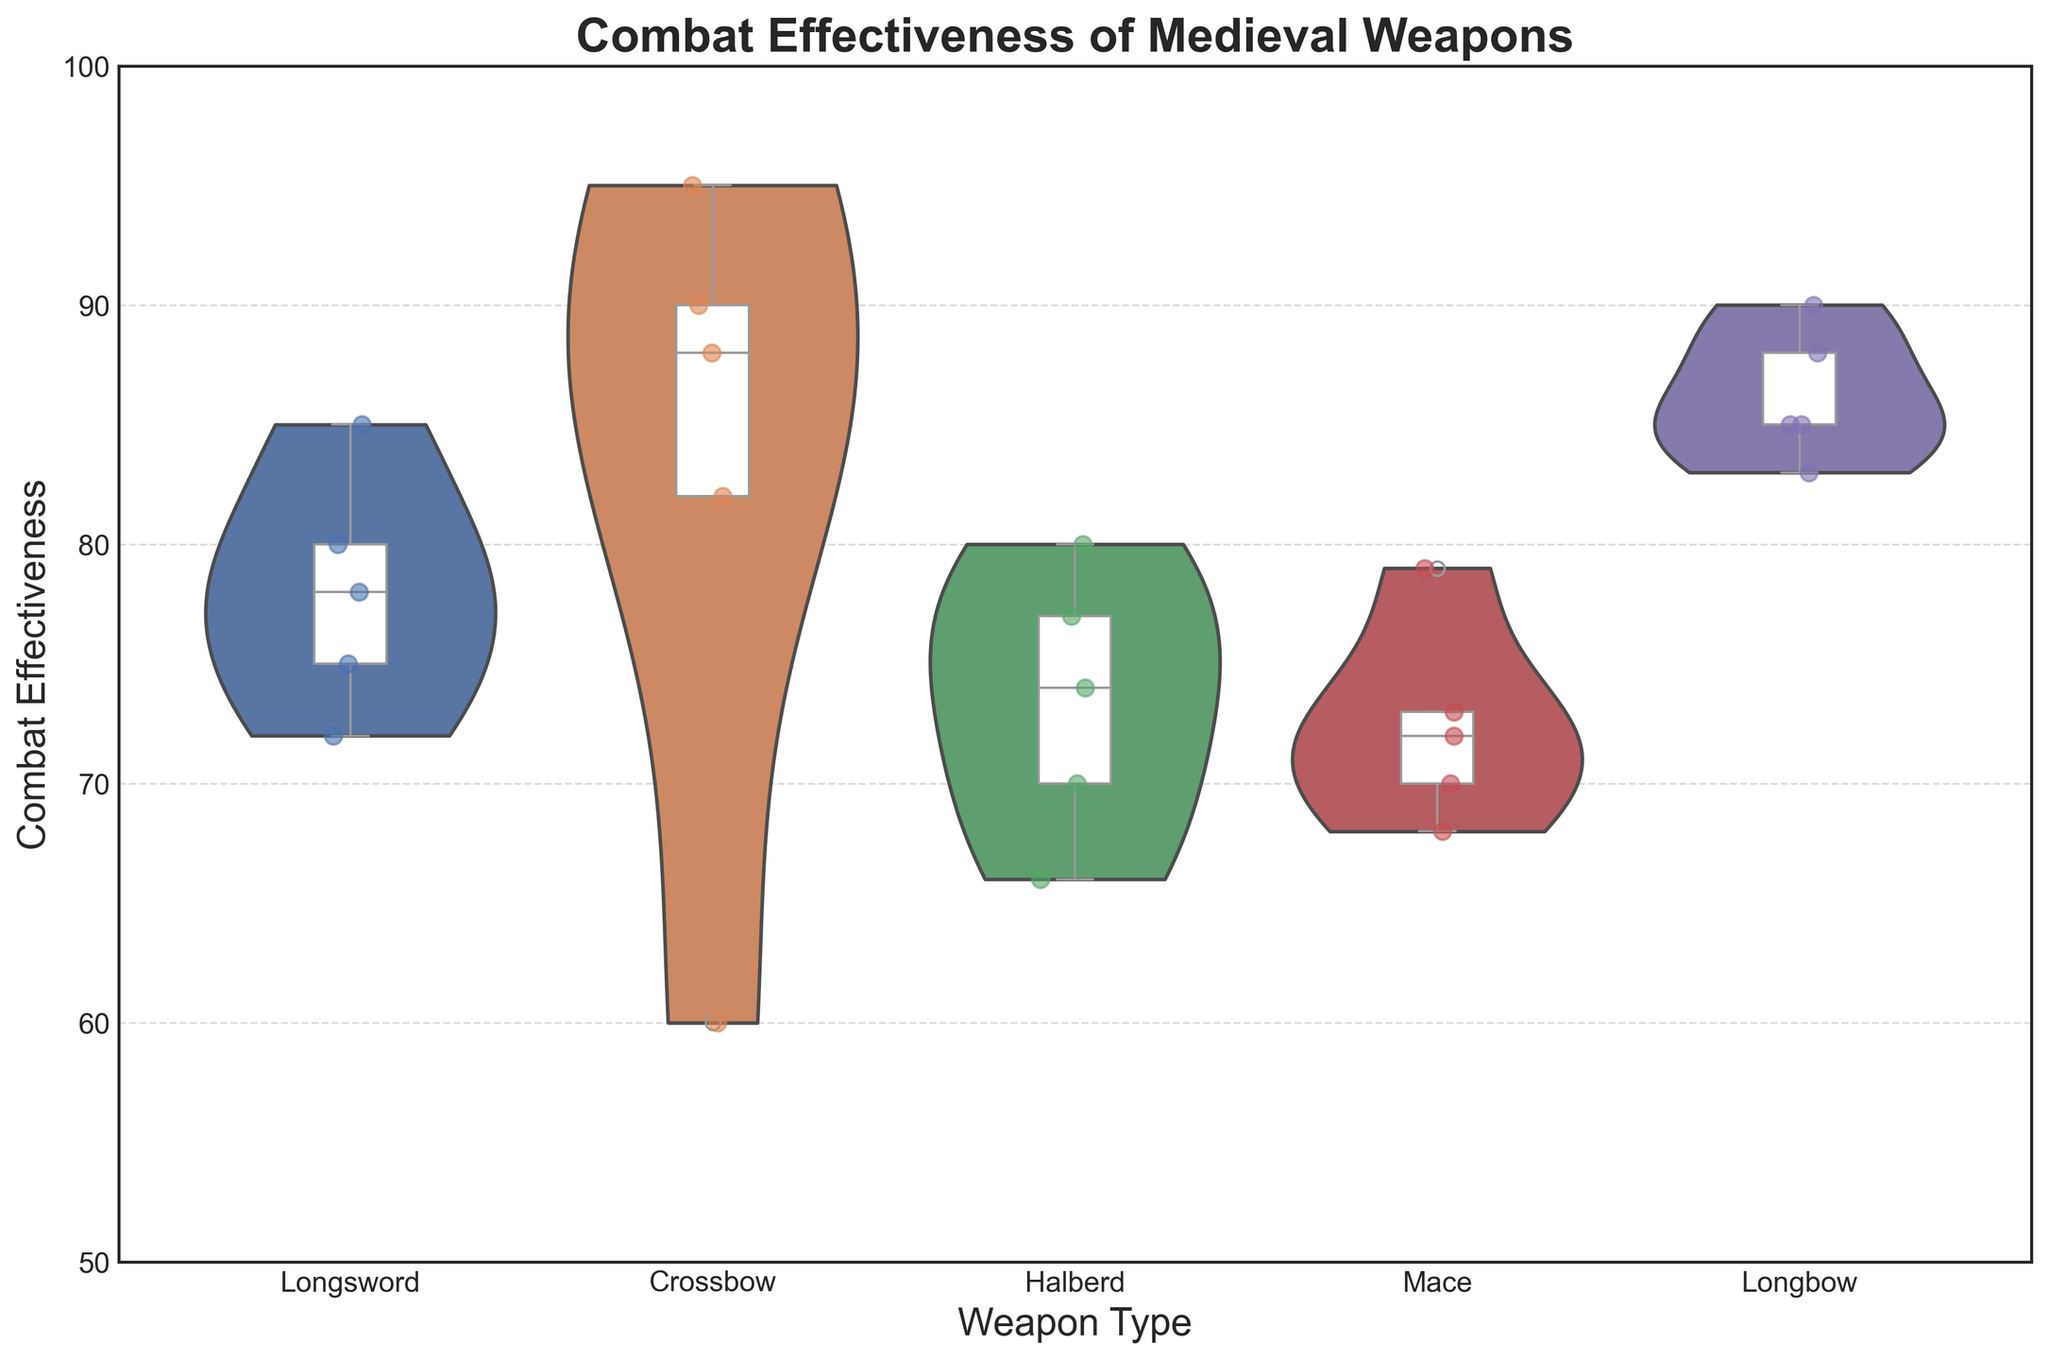what is the title of the figure? The title is typically shown at the top of the figure, which helps identify what the figure is about. In this case, the title is "Combat Effectiveness of Medieval Weapons".
Answer: Combat Effectiveness of Medieval Weapons What is the range of the y-axis? The range of the y-axis is visible on the left side of the figure, indicating the scale of combat effectiveness. In the plot, it ranges from 50 to 100.
Answer: 50 to 100 Which weapon has the highest median combat effectiveness? The median value for each weapon is shown as a line within each box of the box plot. The weapon with the highest median line is the Crossbow.
Answer: Crossbow How does the combat effectiveness of the Longbow compare to the Halberd in open field battles? To answer this, we look at the specific combat effectiveness values for the Longbow and Halberd in open field battles. The Longbow has a combat effectiveness of 90, while the Halberd has 77.
Answer: Longbow is higher What is the difference between the highest and lowest combat effectiveness values for the Crossbow? The highest and lowest values for the Crossbow can be seen in the box plot whiskers or the edge of the violin plot. The highest value is 95, and the lowest value is 60. The difference is 95 - 60.
Answer: 35 Which weapon type shows the widest distribution of combat effectiveness across scenarios? The width of the violin plot indicates the distribution of data. By visually comparing the plots, the Longsword has the widest distribution.
Answer: Longsword What are the median combat effectiveness values for the Longsword and Mace? The median values are represented by the horizontal lines within the boxes of the box plots. The Longsword has a median of approximately 78, and the Mace has a median of around 72.
Answer: Longsword: 78, Mace: 72 Which weapon has the least variation in combat effectiveness across scenarios? Variation is observed by the spread of the violin or box plots. The Mace appears to have the least variation, indicated by its narrow violin plot.
Answer: Mace In which scenario does the Longsword have its highest combat effectiveness? We look for the peak value for Longsword across different scenarios. In this case, the highest effectiveness (85) is in the Open Field Battle scenario.
Answer: Open Field Battle 